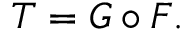<formula> <loc_0><loc_0><loc_500><loc_500>T = G \circ F .</formula> 